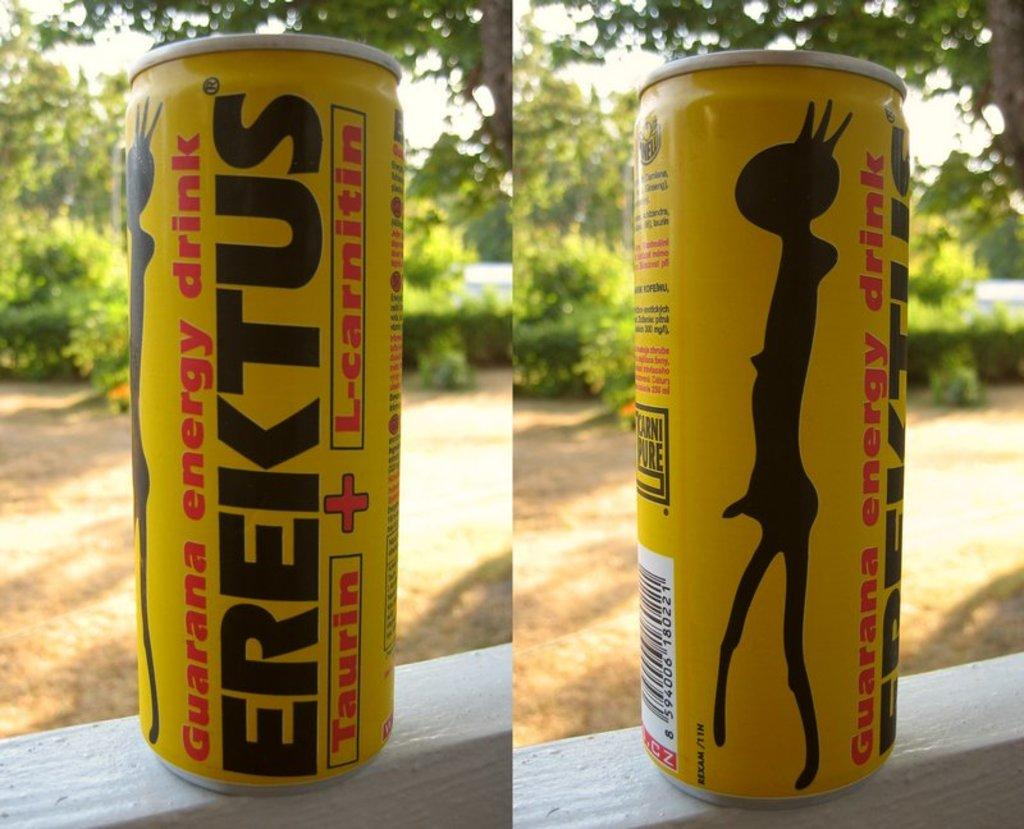Provide a one-sentence caption for the provided image. Two pics of a can of energy drink called Erektus. 